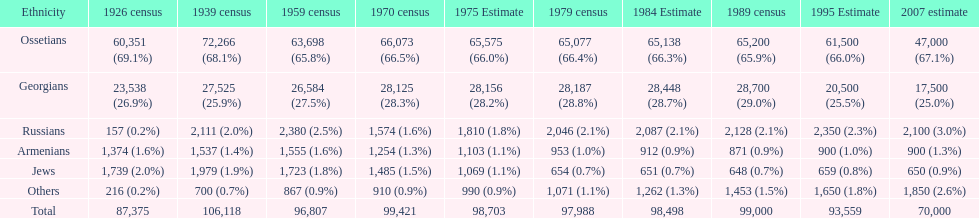How many ethnicity is there? 6. 